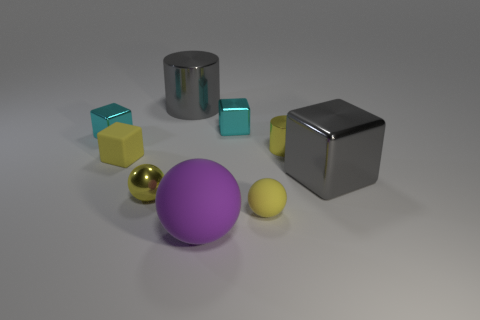Subtract all metal blocks. How many blocks are left? 1 Add 1 tiny yellow metal cylinders. How many objects exist? 10 Subtract 3 blocks. How many blocks are left? 1 Subtract all yellow blocks. How many blocks are left? 3 Subtract all cylinders. How many objects are left? 7 Subtract all small brown matte cylinders. Subtract all tiny cyan blocks. How many objects are left? 7 Add 7 large gray shiny cubes. How many large gray shiny cubes are left? 8 Add 3 tiny yellow matte things. How many tiny yellow matte things exist? 5 Subtract 0 cyan cylinders. How many objects are left? 9 Subtract all red balls. Subtract all gray cylinders. How many balls are left? 3 